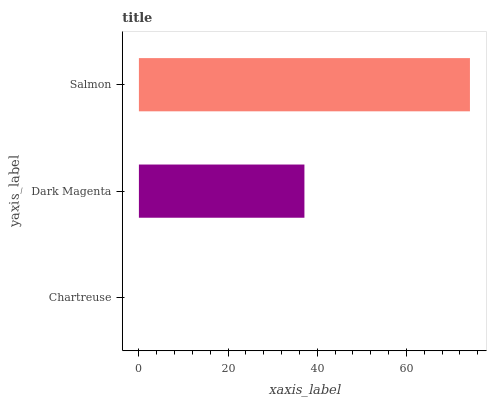Is Chartreuse the minimum?
Answer yes or no. Yes. Is Salmon the maximum?
Answer yes or no. Yes. Is Dark Magenta the minimum?
Answer yes or no. No. Is Dark Magenta the maximum?
Answer yes or no. No. Is Dark Magenta greater than Chartreuse?
Answer yes or no. Yes. Is Chartreuse less than Dark Magenta?
Answer yes or no. Yes. Is Chartreuse greater than Dark Magenta?
Answer yes or no. No. Is Dark Magenta less than Chartreuse?
Answer yes or no. No. Is Dark Magenta the high median?
Answer yes or no. Yes. Is Dark Magenta the low median?
Answer yes or no. Yes. Is Chartreuse the high median?
Answer yes or no. No. Is Chartreuse the low median?
Answer yes or no. No. 